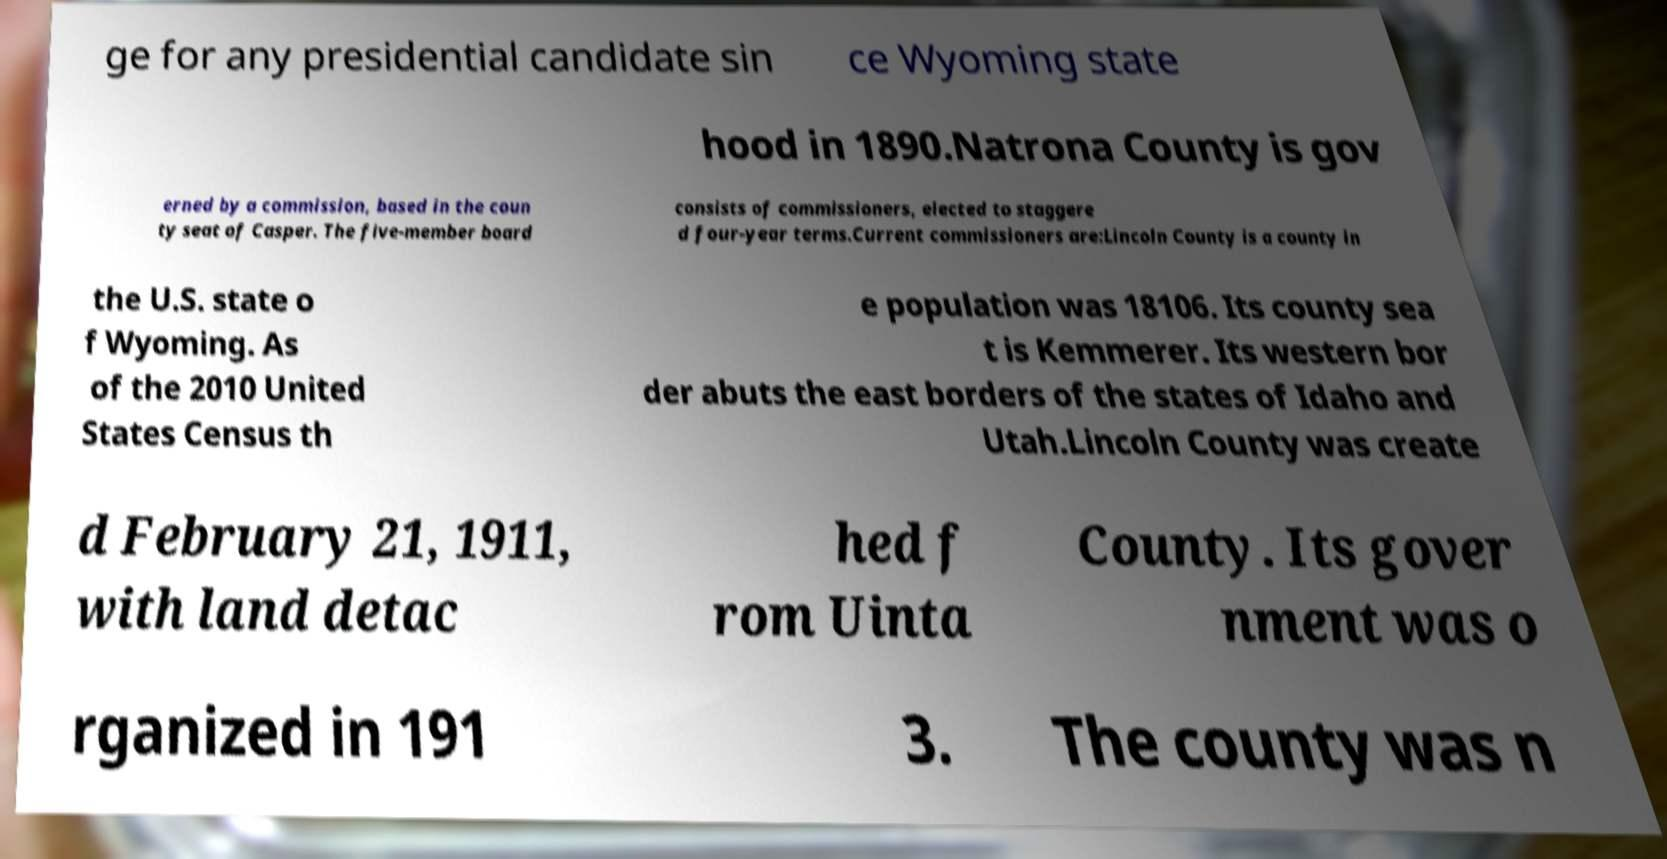There's text embedded in this image that I need extracted. Can you transcribe it verbatim? ge for any presidential candidate sin ce Wyoming state hood in 1890.Natrona County is gov erned by a commission, based in the coun ty seat of Casper. The five-member board consists of commissioners, elected to staggere d four-year terms.Current commissioners are:Lincoln County is a county in the U.S. state o f Wyoming. As of the 2010 United States Census th e population was 18106. Its county sea t is Kemmerer. Its western bor der abuts the east borders of the states of Idaho and Utah.Lincoln County was create d February 21, 1911, with land detac hed f rom Uinta County. Its gover nment was o rganized in 191 3. The county was n 